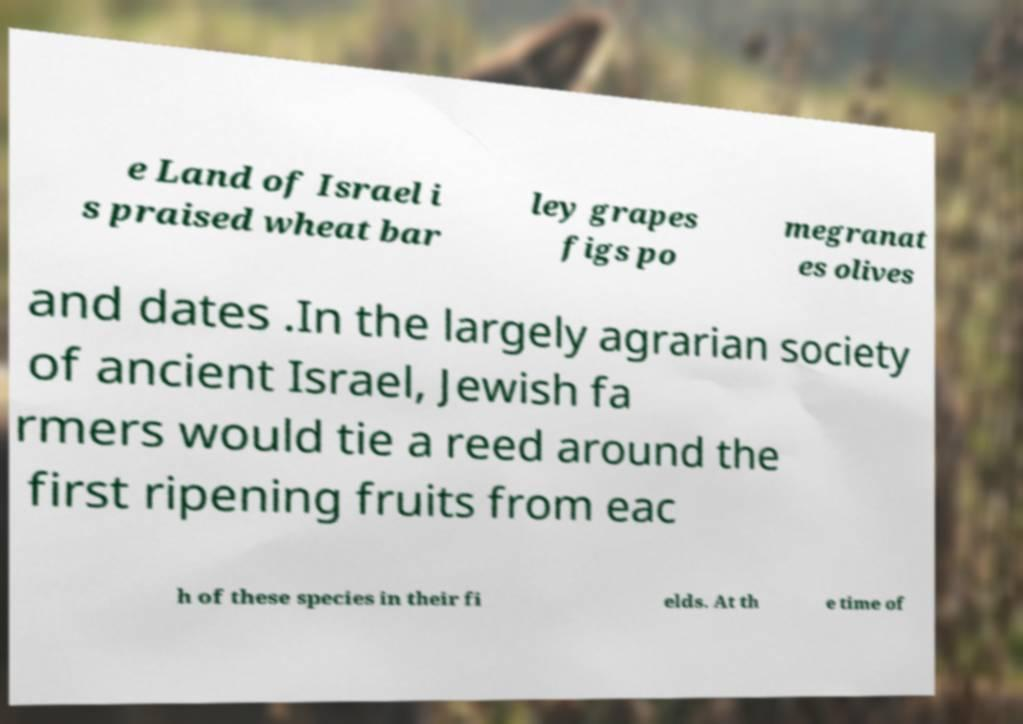What messages or text are displayed in this image? I need them in a readable, typed format. e Land of Israel i s praised wheat bar ley grapes figs po megranat es olives and dates .In the largely agrarian society of ancient Israel, Jewish fa rmers would tie a reed around the first ripening fruits from eac h of these species in their fi elds. At th e time of 